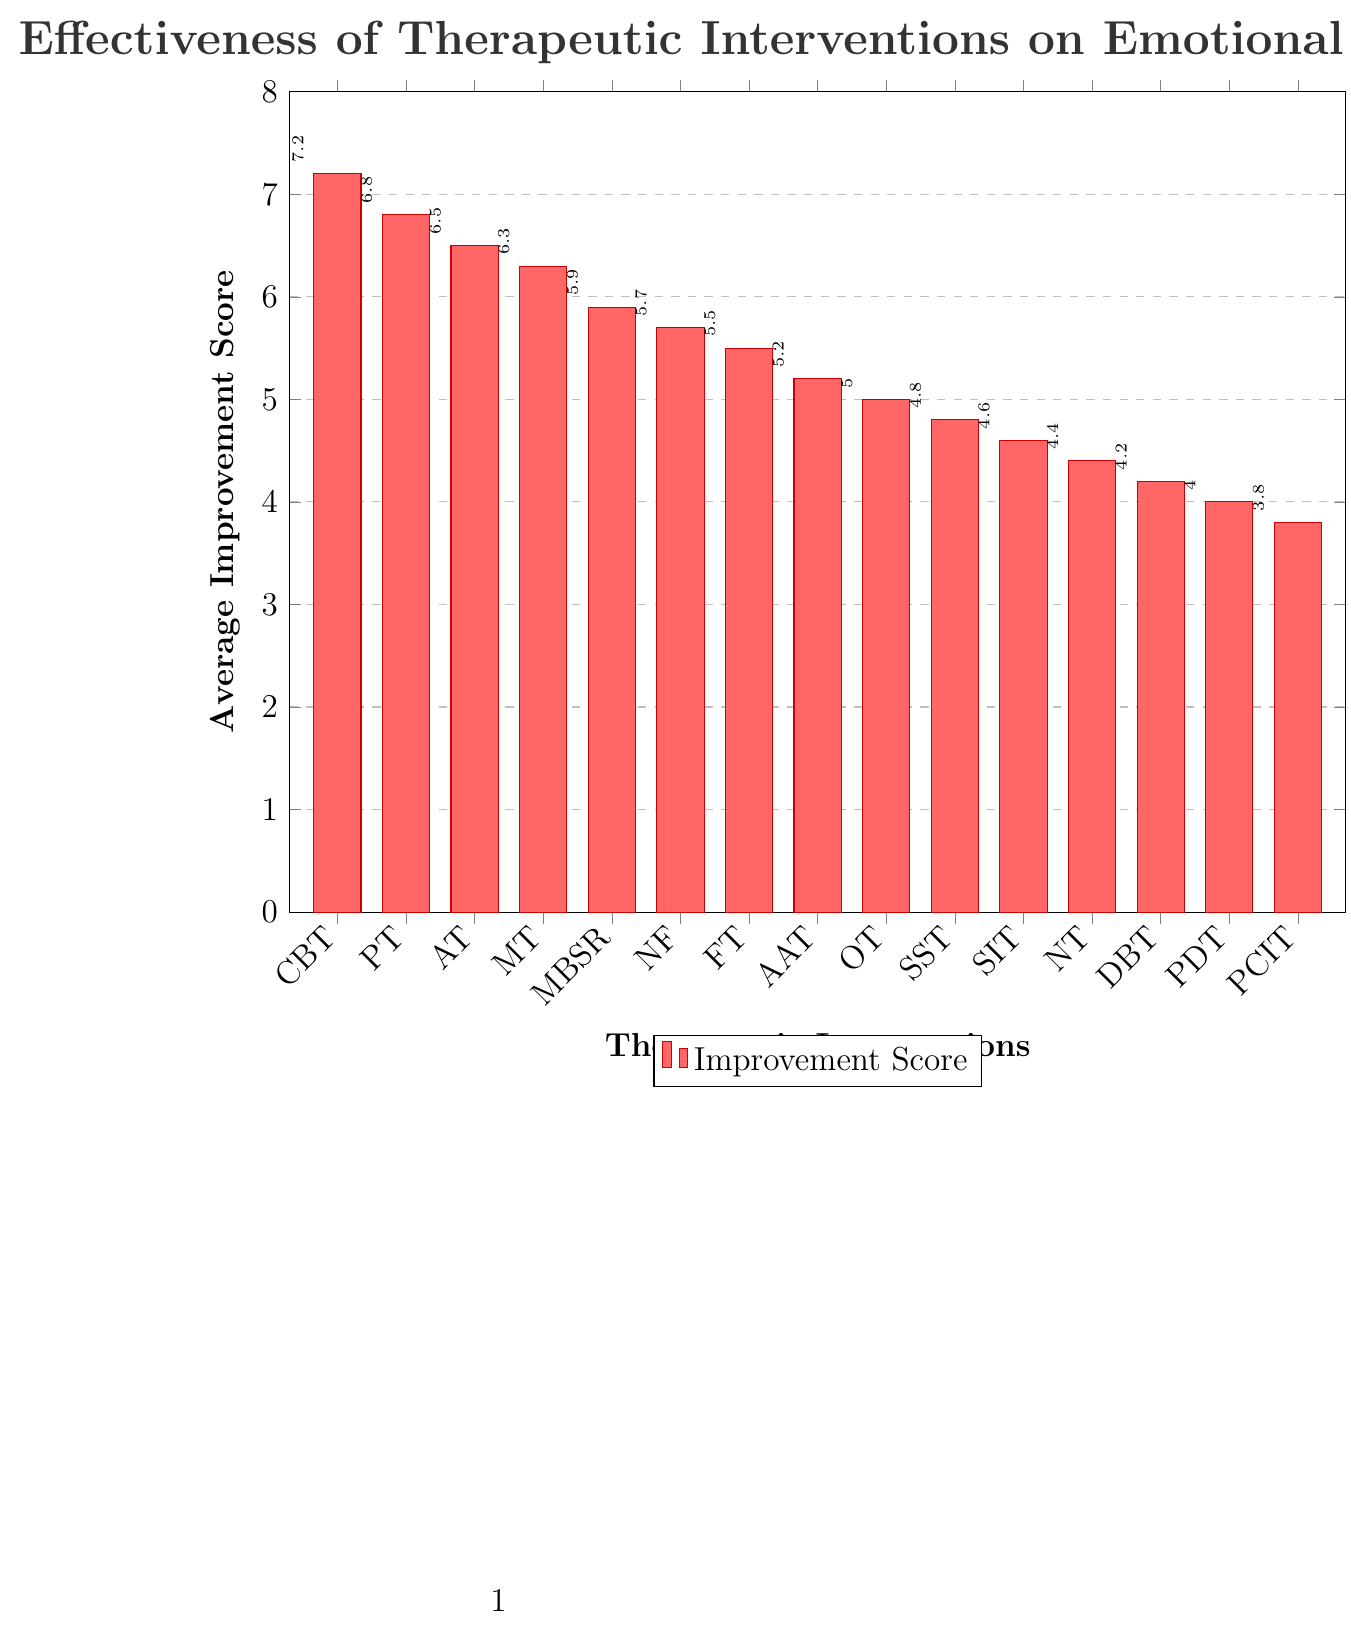What's the highest Average Improvement Score among the therapeutic interventions? First, look at the height of all the bars in the chart. The tallest bar represents the highest score. According to the figure, the bar for Cognitive Behavioral Therapy (CBT) is the tallest with an average improvement score of 7.2.
Answer: 7.2 Which therapeutic intervention has the lowest Average Improvement Score? Look for the shortest bar in the chart. The shortest bar corresponds to Parent-Child Interaction Therapy (PCIT) with a score of 3.8.
Answer: Parent-Child Interaction Therapy What is the difference in the Average Improvement Score between Cognitive Behavioral Therapy and Psychodynamic Therapy? Identify the scores for Cognitive Behavioral Therapy and Psychodynamic Therapy first. CBT has a score of 7.2 and PDT has a score of 4.0. Subtract the lower score from the higher score: 7.2 - 4.0 = 3.2.
Answer: 3.2 How many interventions have an Average Improvement Score greater than 6.0? Count the bars that have heights representing scores above 6.0. These bars are for Cognitive Behavioral Therapy (7.2), Play Therapy (6.8), Art Therapy (6.5), and Music Therapy (6.3). Therefore, there are four such interventions.
Answer: 4 Which therapeutic interventions have an Average Improvement Score between 5.0 and 6.0? Look at the bars whose values fall between 5.0 and 6.0. These interventions are Mindfulness-Based Stress Reduction (5.9), Neurofeedback (5.7), Family Therapy (5.5), and Animal-Assisted Therapy (5.2).
Answer: Mindfulness-Based Stress Reduction, Neurofeedback, Family Therapy, Animal-Assisted Therapy Is the Average Improvement Score for Cognitive Behavioral Therapy more than twice the score of Parent-Child Interaction Therapy? Calculate twice the score of Parent-Child Interaction Therapy: 2 * 3.8 = 7.6. Compare this with the score of Cognitive Behavioral Therapy, which is 7.2. Since 7.2 is less than 7.6, the score is not more than twice.
Answer: No What is the combined Average Improvement Score of Art Therapy, Music Therapy, and Neurofeedback? Identify the scores for Art Therapy (6.5), Music Therapy (6.3), and Neurofeedback (5.7). Add them together: 6.5 + 6.3 + 5.7 = 18.5.
Answer: 18.5 Which therapeutic intervention appears fifth when the bars are ordered from tallest to shortest? First, order the interventions by their scores from highest to lowest: CBT (7.2), PT (6.8), AT (6.5), MT (6.3), MBSR (5.9). The fifth one is Mindfulness-Based Stress Reduction.
Answer: Mindfulness-Based Stress Reduction What is the average score of all therapeutic interventions listed? Sum the scores of all the interventions and then divide by the number of interventions. Total score = 7.2 + 6.8 + 6.5 + 6.3 + 5.9 + 5.7 + 5.5 + 5.2 + 5.0 + 4.8 + 4.6 + 4.4 + 4.2 + 4.0 + 3.8 = 79.9. Number of interventions = 15. Average score = 79.9 / 15 ≈ 5.33.
Answer: 5.33 